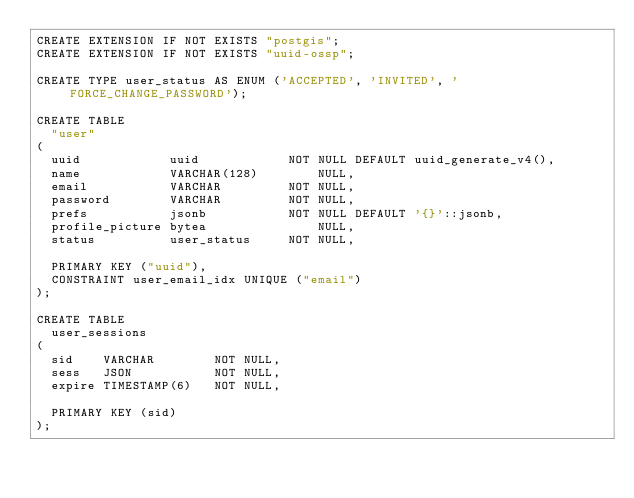Convert code to text. <code><loc_0><loc_0><loc_500><loc_500><_SQL_>CREATE EXTENSION IF NOT EXISTS "postgis";
CREATE EXTENSION IF NOT EXISTS "uuid-ossp";

CREATE TYPE user_status AS ENUM ('ACCEPTED', 'INVITED', 'FORCE_CHANGE_PASSWORD');

CREATE TABLE
  "user"
(
  uuid            uuid            NOT NULL DEFAULT uuid_generate_v4(),
  name            VARCHAR(128)        NULL,
  email           VARCHAR         NOT NULL,
  password        VARCHAR         NOT NULL,
  prefs           jsonb           NOT NULL DEFAULT '{}'::jsonb,
  profile_picture bytea               NULL,
  status          user_status     NOT NULL,

  PRIMARY KEY ("uuid"),
  CONSTRAINT user_email_idx UNIQUE ("email")
);

CREATE TABLE	
  user_sessions	
(	
  sid    VARCHAR        NOT NULL,	
  sess   JSON           NOT NULL,	
  expire TIMESTAMP(6)   NOT NULL,	

  PRIMARY KEY (sid)	
); </code> 